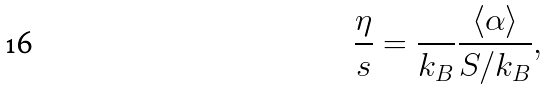Convert formula to latex. <formula><loc_0><loc_0><loc_500><loc_500>\frac { \eta } { s } = \frac { } { k _ { B } } \frac { \langle \alpha \rangle } { S / k _ { B } } ,</formula> 